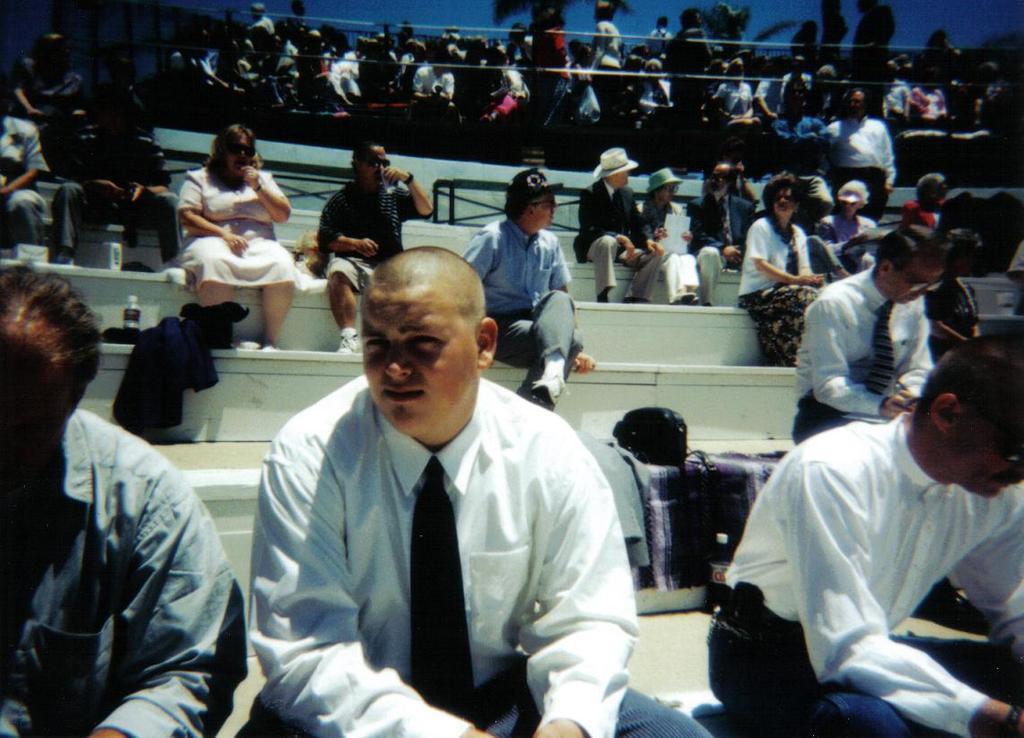How would you summarize this image in a sentence or two? In this image in the foreground there is a crowd sitting on the steps, on the steps there are bottles, cloths kept on it, at the top there is a crowd, there are ropes, fence visible. 